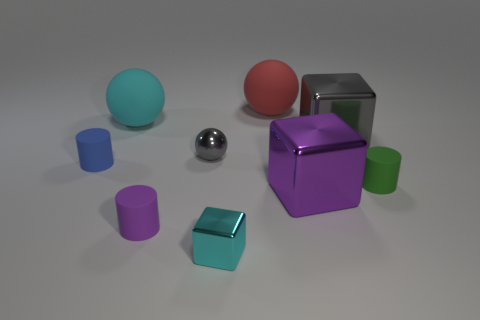Subtract all cyan metallic cubes. How many cubes are left? 2 Add 1 shiny spheres. How many objects exist? 10 Subtract all cylinders. How many objects are left? 6 Add 4 blue matte objects. How many blue matte objects are left? 5 Add 2 cylinders. How many cylinders exist? 5 Subtract 1 cyan balls. How many objects are left? 8 Subtract all yellow cubes. Subtract all yellow cylinders. How many cubes are left? 3 Subtract all tiny cyan matte blocks. Subtract all shiny balls. How many objects are left? 8 